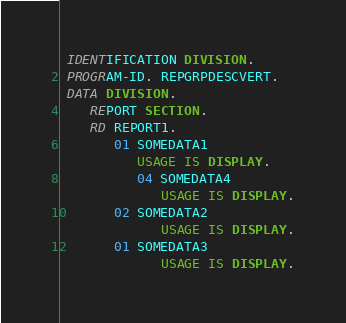Convert code to text. <code><loc_0><loc_0><loc_500><loc_500><_COBOL_> IDENTIFICATION DIVISION.
 PROGRAM-ID. REPGRPDESCVERT.
 DATA DIVISION.
    REPORT SECTION.
    RD REPORT1.
       01 SOMEDATA1
          USAGE IS DISPLAY.
          04 SOMEDATA4
             USAGE IS DISPLAY.
       02 SOMEDATA2
             USAGE IS DISPLAY.
       01 SOMEDATA3
             USAGE IS DISPLAY.</code> 